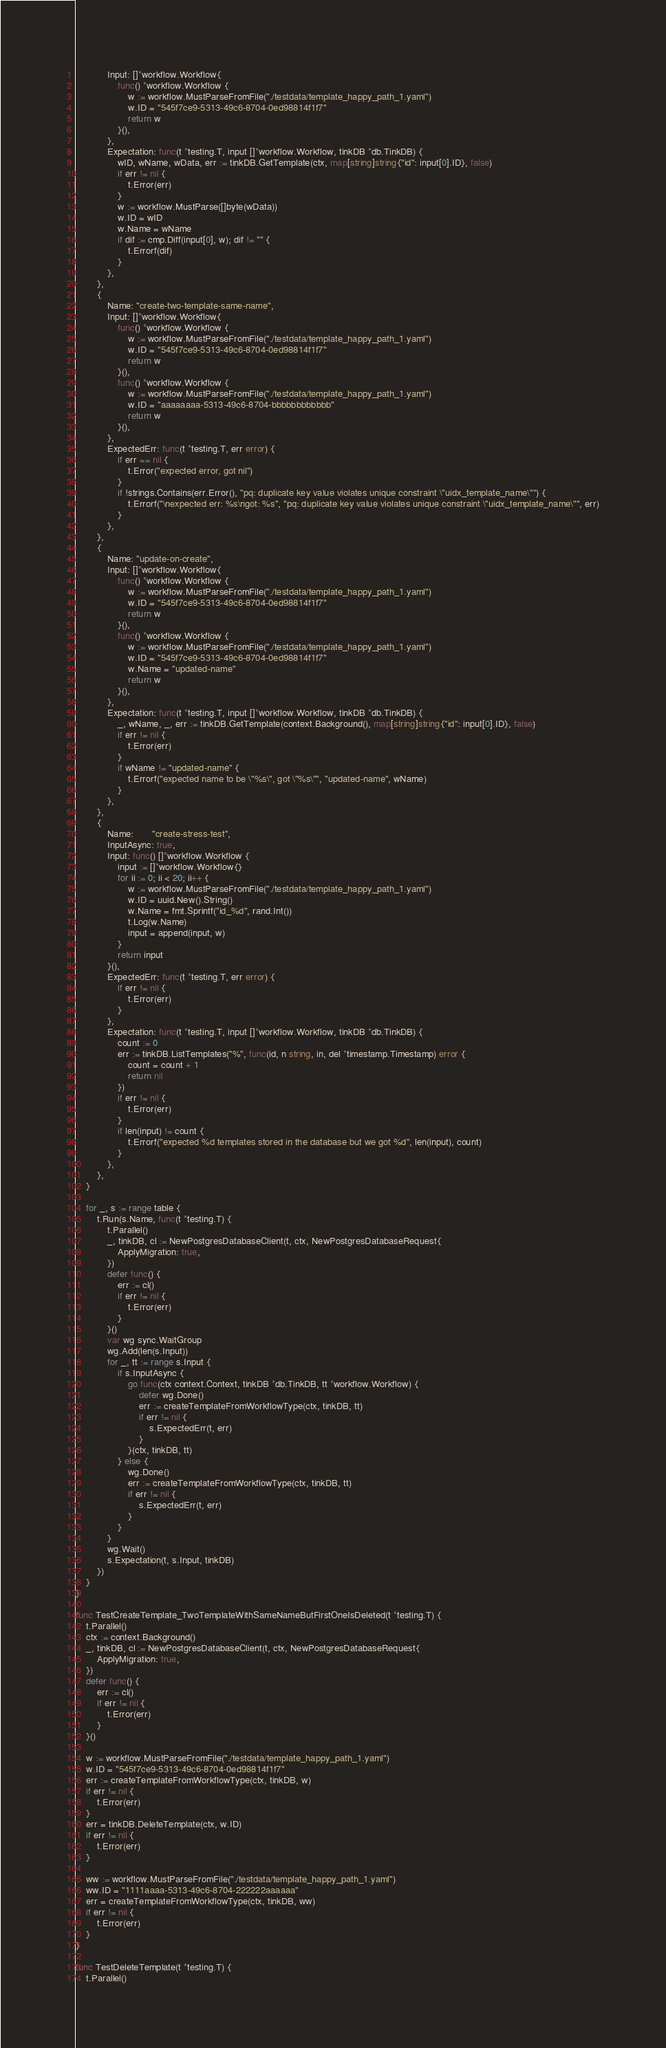<code> <loc_0><loc_0><loc_500><loc_500><_Go_>			Input: []*workflow.Workflow{
				func() *workflow.Workflow {
					w := workflow.MustParseFromFile("./testdata/template_happy_path_1.yaml")
					w.ID = "545f7ce9-5313-49c6-8704-0ed98814f1f7"
					return w
				}(),
			},
			Expectation: func(t *testing.T, input []*workflow.Workflow, tinkDB *db.TinkDB) {
				wID, wName, wData, err := tinkDB.GetTemplate(ctx, map[string]string{"id": input[0].ID}, false)
				if err != nil {
					t.Error(err)
				}
				w := workflow.MustParse([]byte(wData))
				w.ID = wID
				w.Name = wName
				if dif := cmp.Diff(input[0], w); dif != "" {
					t.Errorf(dif)
				}
			},
		},
		{
			Name: "create-two-template-same-name",
			Input: []*workflow.Workflow{
				func() *workflow.Workflow {
					w := workflow.MustParseFromFile("./testdata/template_happy_path_1.yaml")
					w.ID = "545f7ce9-5313-49c6-8704-0ed98814f1f7"
					return w
				}(),
				func() *workflow.Workflow {
					w := workflow.MustParseFromFile("./testdata/template_happy_path_1.yaml")
					w.ID = "aaaaaaaa-5313-49c6-8704-bbbbbbbbbbbb"
					return w
				}(),
			},
			ExpectedErr: func(t *testing.T, err error) {
				if err == nil {
					t.Error("expected error, got nil")
				}
				if !strings.Contains(err.Error(), "pq: duplicate key value violates unique constraint \"uidx_template_name\"") {
					t.Errorf("\nexpected err: %s\ngot: %s", "pq: duplicate key value violates unique constraint \"uidx_template_name\"", err)
				}
			},
		},
		{
			Name: "update-on-create",
			Input: []*workflow.Workflow{
				func() *workflow.Workflow {
					w := workflow.MustParseFromFile("./testdata/template_happy_path_1.yaml")
					w.ID = "545f7ce9-5313-49c6-8704-0ed98814f1f7"
					return w
				}(),
				func() *workflow.Workflow {
					w := workflow.MustParseFromFile("./testdata/template_happy_path_1.yaml")
					w.ID = "545f7ce9-5313-49c6-8704-0ed98814f1f7"
					w.Name = "updated-name"
					return w
				}(),
			},
			Expectation: func(t *testing.T, input []*workflow.Workflow, tinkDB *db.TinkDB) {
				_, wName, _, err := tinkDB.GetTemplate(context.Background(), map[string]string{"id": input[0].ID}, false)
				if err != nil {
					t.Error(err)
				}
				if wName != "updated-name" {
					t.Errorf("expected name to be \"%s\", got \"%s\"", "updated-name", wName)
				}
			},
		},
		{
			Name:       "create-stress-test",
			InputAsync: true,
			Input: func() []*workflow.Workflow {
				input := []*workflow.Workflow{}
				for ii := 0; ii < 20; ii++ {
					w := workflow.MustParseFromFile("./testdata/template_happy_path_1.yaml")
					w.ID = uuid.New().String()
					w.Name = fmt.Sprintf("id_%d", rand.Int())
					t.Log(w.Name)
					input = append(input, w)
				}
				return input
			}(),
			ExpectedErr: func(t *testing.T, err error) {
				if err != nil {
					t.Error(err)
				}
			},
			Expectation: func(t *testing.T, input []*workflow.Workflow, tinkDB *db.TinkDB) {
				count := 0
				err := tinkDB.ListTemplates("%", func(id, n string, in, del *timestamp.Timestamp) error {
					count = count + 1
					return nil
				})
				if err != nil {
					t.Error(err)
				}
				if len(input) != count {
					t.Errorf("expected %d templates stored in the database but we got %d", len(input), count)
				}
			},
		},
	}

	for _, s := range table {
		t.Run(s.Name, func(t *testing.T) {
			t.Parallel()
			_, tinkDB, cl := NewPostgresDatabaseClient(t, ctx, NewPostgresDatabaseRequest{
				ApplyMigration: true,
			})
			defer func() {
				err := cl()
				if err != nil {
					t.Error(err)
				}
			}()
			var wg sync.WaitGroup
			wg.Add(len(s.Input))
			for _, tt := range s.Input {
				if s.InputAsync {
					go func(ctx context.Context, tinkDB *db.TinkDB, tt *workflow.Workflow) {
						defer wg.Done()
						err := createTemplateFromWorkflowType(ctx, tinkDB, tt)
						if err != nil {
							s.ExpectedErr(t, err)
						}
					}(ctx, tinkDB, tt)
				} else {
					wg.Done()
					err := createTemplateFromWorkflowType(ctx, tinkDB, tt)
					if err != nil {
						s.ExpectedErr(t, err)
					}
				}
			}
			wg.Wait()
			s.Expectation(t, s.Input, tinkDB)
		})
	}
}

func TestCreateTemplate_TwoTemplateWithSameNameButFirstOneIsDeleted(t *testing.T) {
	t.Parallel()
	ctx := context.Background()
	_, tinkDB, cl := NewPostgresDatabaseClient(t, ctx, NewPostgresDatabaseRequest{
		ApplyMigration: true,
	})
	defer func() {
		err := cl()
		if err != nil {
			t.Error(err)
		}
	}()

	w := workflow.MustParseFromFile("./testdata/template_happy_path_1.yaml")
	w.ID = "545f7ce9-5313-49c6-8704-0ed98814f1f7"
	err := createTemplateFromWorkflowType(ctx, tinkDB, w)
	if err != nil {
		t.Error(err)
	}
	err = tinkDB.DeleteTemplate(ctx, w.ID)
	if err != nil {
		t.Error(err)
	}

	ww := workflow.MustParseFromFile("./testdata/template_happy_path_1.yaml")
	ww.ID = "1111aaaa-5313-49c6-8704-222222aaaaaa"
	err = createTemplateFromWorkflowType(ctx, tinkDB, ww)
	if err != nil {
		t.Error(err)
	}
}

func TestDeleteTemplate(t *testing.T) {
	t.Parallel()</code> 